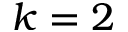<formula> <loc_0><loc_0><loc_500><loc_500>k = 2</formula> 